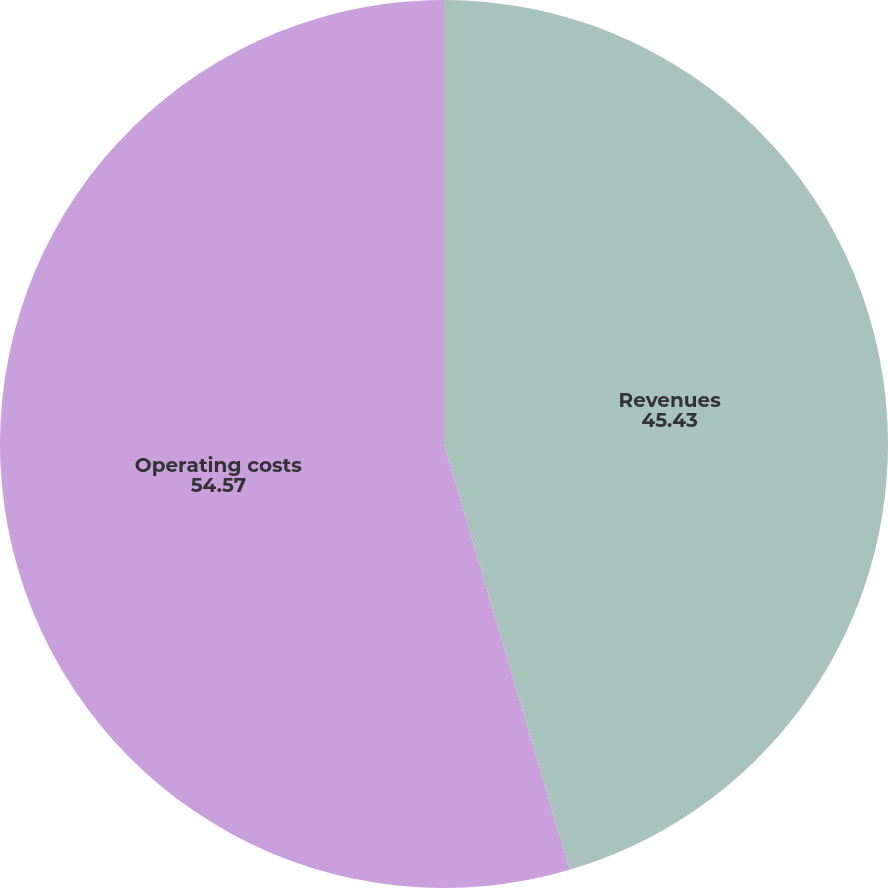Convert chart to OTSL. <chart><loc_0><loc_0><loc_500><loc_500><pie_chart><fcel>Revenues<fcel>Operating costs<nl><fcel>45.43%<fcel>54.57%<nl></chart> 